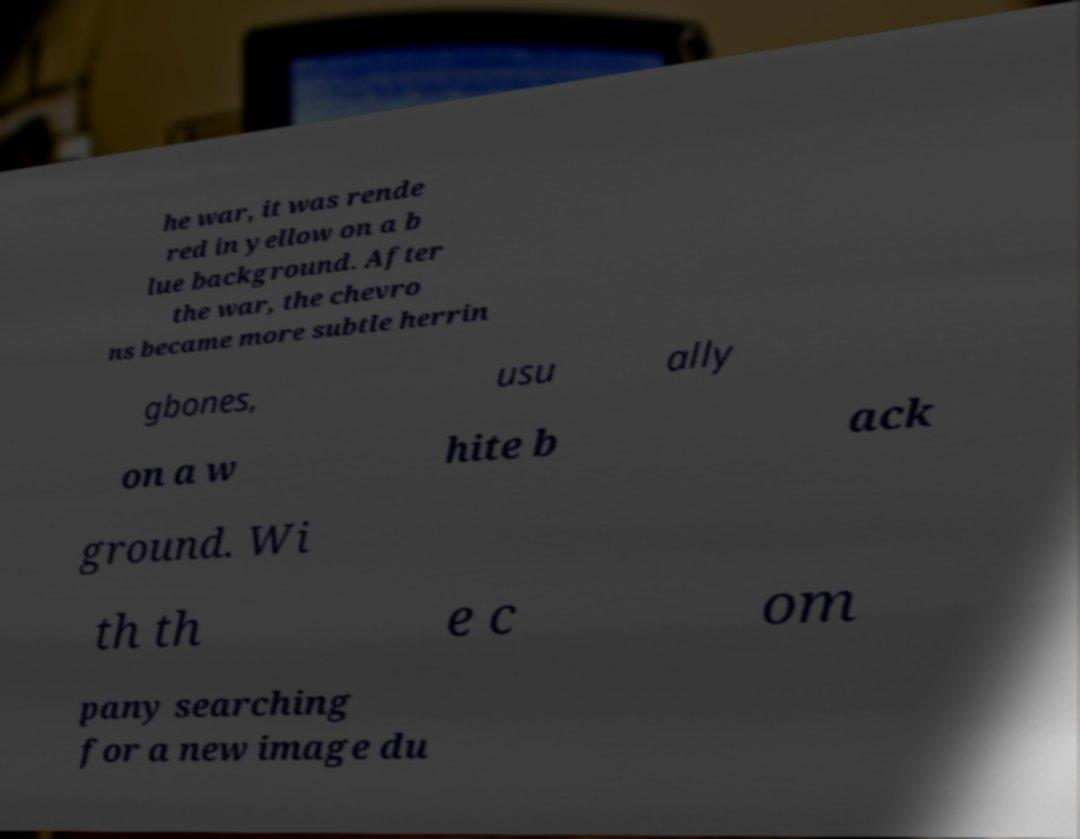Can you accurately transcribe the text from the provided image for me? he war, it was rende red in yellow on a b lue background. After the war, the chevro ns became more subtle herrin gbones, usu ally on a w hite b ack ground. Wi th th e c om pany searching for a new image du 